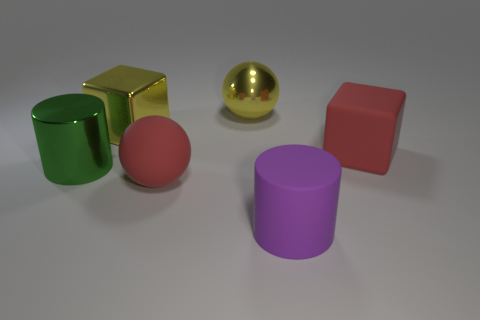Add 3 yellow things. How many objects exist? 9 Subtract all blocks. How many objects are left? 4 Add 1 large blocks. How many large blocks are left? 3 Add 5 tiny gray shiny balls. How many tiny gray shiny balls exist? 5 Subtract 0 purple cubes. How many objects are left? 6 Subtract all big matte blocks. Subtract all purple cylinders. How many objects are left? 4 